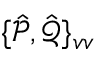<formula> <loc_0><loc_0><loc_500><loc_500>\{ \hat { \mathcal { P } } , \hat { \mathcal { Q } } \} _ { v v }</formula> 